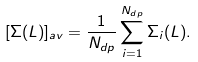Convert formula to latex. <formula><loc_0><loc_0><loc_500><loc_500>[ \Sigma ( L ) ] _ { a v } = \frac { 1 } { N _ { d p } } \sum _ { i = 1 } ^ { N _ { d p } } \Sigma _ { i } ( L ) .</formula> 